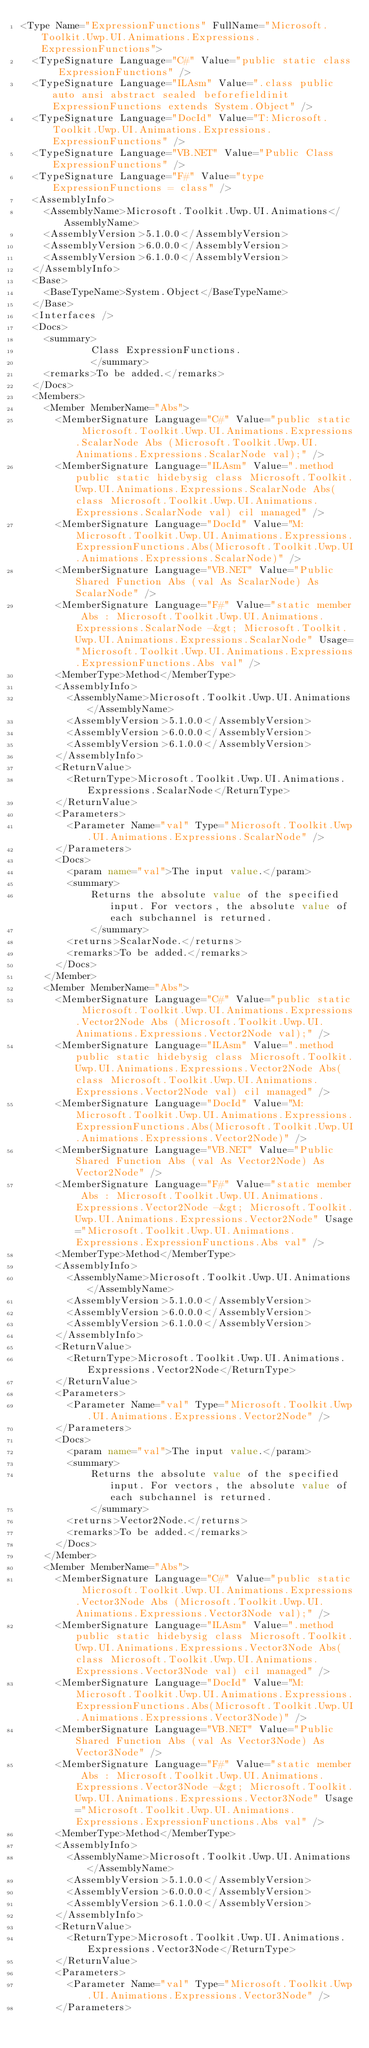<code> <loc_0><loc_0><loc_500><loc_500><_XML_><Type Name="ExpressionFunctions" FullName="Microsoft.Toolkit.Uwp.UI.Animations.Expressions.ExpressionFunctions">
  <TypeSignature Language="C#" Value="public static class ExpressionFunctions" />
  <TypeSignature Language="ILAsm" Value=".class public auto ansi abstract sealed beforefieldinit ExpressionFunctions extends System.Object" />
  <TypeSignature Language="DocId" Value="T:Microsoft.Toolkit.Uwp.UI.Animations.Expressions.ExpressionFunctions" />
  <TypeSignature Language="VB.NET" Value="Public Class ExpressionFunctions" />
  <TypeSignature Language="F#" Value="type ExpressionFunctions = class" />
  <AssemblyInfo>
    <AssemblyName>Microsoft.Toolkit.Uwp.UI.Animations</AssemblyName>
    <AssemblyVersion>5.1.0.0</AssemblyVersion>
    <AssemblyVersion>6.0.0.0</AssemblyVersion>
    <AssemblyVersion>6.1.0.0</AssemblyVersion>
  </AssemblyInfo>
  <Base>
    <BaseTypeName>System.Object</BaseTypeName>
  </Base>
  <Interfaces />
  <Docs>
    <summary>
            Class ExpressionFunctions.
            </summary>
    <remarks>To be added.</remarks>
  </Docs>
  <Members>
    <Member MemberName="Abs">
      <MemberSignature Language="C#" Value="public static Microsoft.Toolkit.Uwp.UI.Animations.Expressions.ScalarNode Abs (Microsoft.Toolkit.Uwp.UI.Animations.Expressions.ScalarNode val);" />
      <MemberSignature Language="ILAsm" Value=".method public static hidebysig class Microsoft.Toolkit.Uwp.UI.Animations.Expressions.ScalarNode Abs(class Microsoft.Toolkit.Uwp.UI.Animations.Expressions.ScalarNode val) cil managed" />
      <MemberSignature Language="DocId" Value="M:Microsoft.Toolkit.Uwp.UI.Animations.Expressions.ExpressionFunctions.Abs(Microsoft.Toolkit.Uwp.UI.Animations.Expressions.ScalarNode)" />
      <MemberSignature Language="VB.NET" Value="Public Shared Function Abs (val As ScalarNode) As ScalarNode" />
      <MemberSignature Language="F#" Value="static member Abs : Microsoft.Toolkit.Uwp.UI.Animations.Expressions.ScalarNode -&gt; Microsoft.Toolkit.Uwp.UI.Animations.Expressions.ScalarNode" Usage="Microsoft.Toolkit.Uwp.UI.Animations.Expressions.ExpressionFunctions.Abs val" />
      <MemberType>Method</MemberType>
      <AssemblyInfo>
        <AssemblyName>Microsoft.Toolkit.Uwp.UI.Animations</AssemblyName>
        <AssemblyVersion>5.1.0.0</AssemblyVersion>
        <AssemblyVersion>6.0.0.0</AssemblyVersion>
        <AssemblyVersion>6.1.0.0</AssemblyVersion>
      </AssemblyInfo>
      <ReturnValue>
        <ReturnType>Microsoft.Toolkit.Uwp.UI.Animations.Expressions.ScalarNode</ReturnType>
      </ReturnValue>
      <Parameters>
        <Parameter Name="val" Type="Microsoft.Toolkit.Uwp.UI.Animations.Expressions.ScalarNode" />
      </Parameters>
      <Docs>
        <param name="val">The input value.</param>
        <summary>
            Returns the absolute value of the specified input. For vectors, the absolute value of each subchannel is returned.
            </summary>
        <returns>ScalarNode.</returns>
        <remarks>To be added.</remarks>
      </Docs>
    </Member>
    <Member MemberName="Abs">
      <MemberSignature Language="C#" Value="public static Microsoft.Toolkit.Uwp.UI.Animations.Expressions.Vector2Node Abs (Microsoft.Toolkit.Uwp.UI.Animations.Expressions.Vector2Node val);" />
      <MemberSignature Language="ILAsm" Value=".method public static hidebysig class Microsoft.Toolkit.Uwp.UI.Animations.Expressions.Vector2Node Abs(class Microsoft.Toolkit.Uwp.UI.Animations.Expressions.Vector2Node val) cil managed" />
      <MemberSignature Language="DocId" Value="M:Microsoft.Toolkit.Uwp.UI.Animations.Expressions.ExpressionFunctions.Abs(Microsoft.Toolkit.Uwp.UI.Animations.Expressions.Vector2Node)" />
      <MemberSignature Language="VB.NET" Value="Public Shared Function Abs (val As Vector2Node) As Vector2Node" />
      <MemberSignature Language="F#" Value="static member Abs : Microsoft.Toolkit.Uwp.UI.Animations.Expressions.Vector2Node -&gt; Microsoft.Toolkit.Uwp.UI.Animations.Expressions.Vector2Node" Usage="Microsoft.Toolkit.Uwp.UI.Animations.Expressions.ExpressionFunctions.Abs val" />
      <MemberType>Method</MemberType>
      <AssemblyInfo>
        <AssemblyName>Microsoft.Toolkit.Uwp.UI.Animations</AssemblyName>
        <AssemblyVersion>5.1.0.0</AssemblyVersion>
        <AssemblyVersion>6.0.0.0</AssemblyVersion>
        <AssemblyVersion>6.1.0.0</AssemblyVersion>
      </AssemblyInfo>
      <ReturnValue>
        <ReturnType>Microsoft.Toolkit.Uwp.UI.Animations.Expressions.Vector2Node</ReturnType>
      </ReturnValue>
      <Parameters>
        <Parameter Name="val" Type="Microsoft.Toolkit.Uwp.UI.Animations.Expressions.Vector2Node" />
      </Parameters>
      <Docs>
        <param name="val">The input value.</param>
        <summary>
            Returns the absolute value of the specified input. For vectors, the absolute value of each subchannel is returned.
            </summary>
        <returns>Vector2Node.</returns>
        <remarks>To be added.</remarks>
      </Docs>
    </Member>
    <Member MemberName="Abs">
      <MemberSignature Language="C#" Value="public static Microsoft.Toolkit.Uwp.UI.Animations.Expressions.Vector3Node Abs (Microsoft.Toolkit.Uwp.UI.Animations.Expressions.Vector3Node val);" />
      <MemberSignature Language="ILAsm" Value=".method public static hidebysig class Microsoft.Toolkit.Uwp.UI.Animations.Expressions.Vector3Node Abs(class Microsoft.Toolkit.Uwp.UI.Animations.Expressions.Vector3Node val) cil managed" />
      <MemberSignature Language="DocId" Value="M:Microsoft.Toolkit.Uwp.UI.Animations.Expressions.ExpressionFunctions.Abs(Microsoft.Toolkit.Uwp.UI.Animations.Expressions.Vector3Node)" />
      <MemberSignature Language="VB.NET" Value="Public Shared Function Abs (val As Vector3Node) As Vector3Node" />
      <MemberSignature Language="F#" Value="static member Abs : Microsoft.Toolkit.Uwp.UI.Animations.Expressions.Vector3Node -&gt; Microsoft.Toolkit.Uwp.UI.Animations.Expressions.Vector3Node" Usage="Microsoft.Toolkit.Uwp.UI.Animations.Expressions.ExpressionFunctions.Abs val" />
      <MemberType>Method</MemberType>
      <AssemblyInfo>
        <AssemblyName>Microsoft.Toolkit.Uwp.UI.Animations</AssemblyName>
        <AssemblyVersion>5.1.0.0</AssemblyVersion>
        <AssemblyVersion>6.0.0.0</AssemblyVersion>
        <AssemblyVersion>6.1.0.0</AssemblyVersion>
      </AssemblyInfo>
      <ReturnValue>
        <ReturnType>Microsoft.Toolkit.Uwp.UI.Animations.Expressions.Vector3Node</ReturnType>
      </ReturnValue>
      <Parameters>
        <Parameter Name="val" Type="Microsoft.Toolkit.Uwp.UI.Animations.Expressions.Vector3Node" />
      </Parameters></code> 